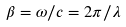<formula> <loc_0><loc_0><loc_500><loc_500>\beta = \omega / c = 2 \pi / \lambda</formula> 